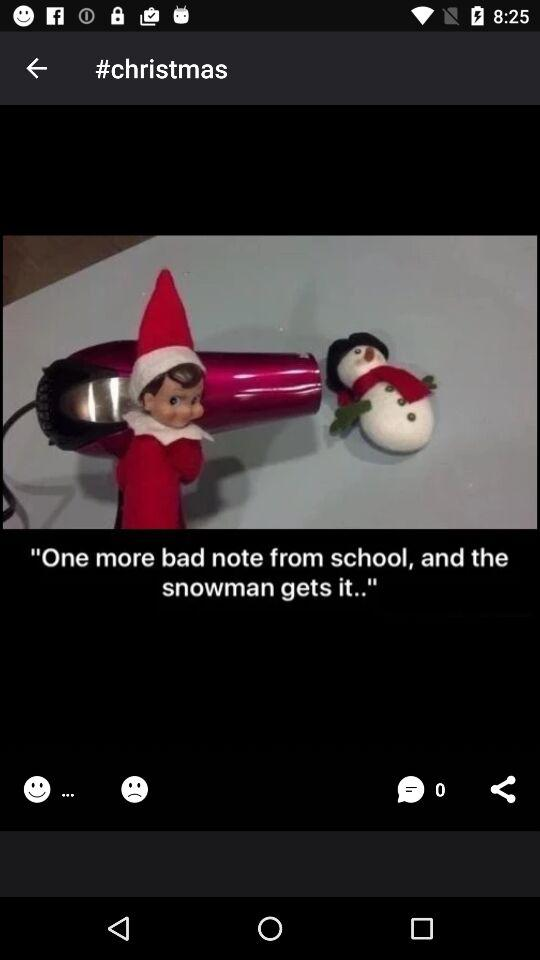What is the name of the application?
When the provided information is insufficient, respond with <no answer>. <no answer> 